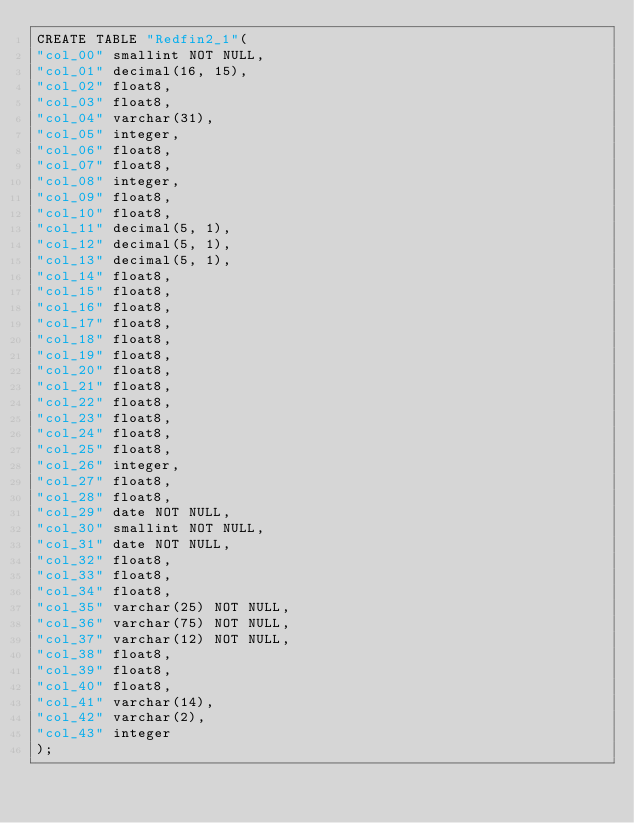<code> <loc_0><loc_0><loc_500><loc_500><_SQL_>CREATE TABLE "Redfin2_1"(
"col_00" smallint NOT NULL,
"col_01" decimal(16, 15),
"col_02" float8,
"col_03" float8,
"col_04" varchar(31),
"col_05" integer,
"col_06" float8,
"col_07" float8,
"col_08" integer,
"col_09" float8,
"col_10" float8,
"col_11" decimal(5, 1),
"col_12" decimal(5, 1),
"col_13" decimal(5, 1),
"col_14" float8,
"col_15" float8,
"col_16" float8,
"col_17" float8,
"col_18" float8,
"col_19" float8,
"col_20" float8,
"col_21" float8,
"col_22" float8,
"col_23" float8,
"col_24" float8,
"col_25" float8,
"col_26" integer,
"col_27" float8,
"col_28" float8,
"col_29" date NOT NULL,
"col_30" smallint NOT NULL,
"col_31" date NOT NULL,
"col_32" float8,
"col_33" float8,
"col_34" float8,
"col_35" varchar(25) NOT NULL,
"col_36" varchar(75) NOT NULL,
"col_37" varchar(12) NOT NULL,
"col_38" float8,
"col_39" float8,
"col_40" float8,
"col_41" varchar(14),
"col_42" varchar(2),
"col_43" integer
);
</code> 